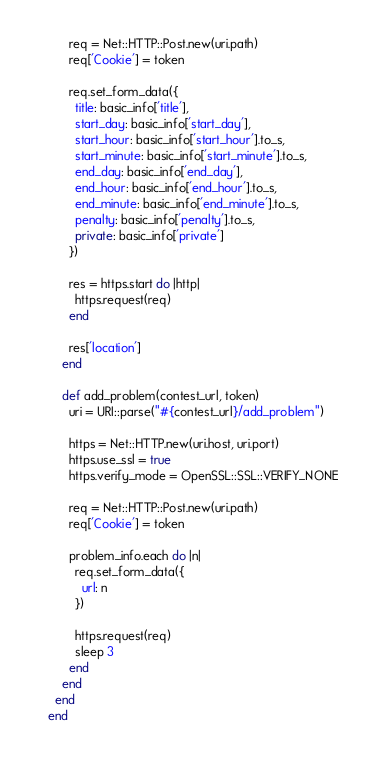Convert code to text. <code><loc_0><loc_0><loc_500><loc_500><_Ruby_>
      req = Net::HTTP::Post.new(uri.path)
      req['Cookie'] = token

      req.set_form_data({
        title: basic_info['title'],
        start_day: basic_info['start_day'],
        start_hour: basic_info['start_hour'].to_s,
        start_minute: basic_info['start_minute'].to_s,
        end_day: basic_info['end_day'],
        end_hour: basic_info['end_hour'].to_s,
        end_minute: basic_info['end_minute'].to_s,
        penalty: basic_info['penalty'].to_s,
        private: basic_info['private']
      })

      res = https.start do |http|
        https.request(req)
      end

      res['location']
    end

    def add_problem(contest_url, token)
      uri = URI::parse("#{contest_url}/add_problem")

      https = Net::HTTP.new(uri.host, uri.port)
      https.use_ssl = true
      https.verify_mode = OpenSSL::SSL::VERIFY_NONE

      req = Net::HTTP::Post.new(uri.path)
      req['Cookie'] = token

      problem_info.each do |n|
        req.set_form_data({
          url: n
        })

        https.request(req)
        sleep 3
      end
    end
  end
end
</code> 